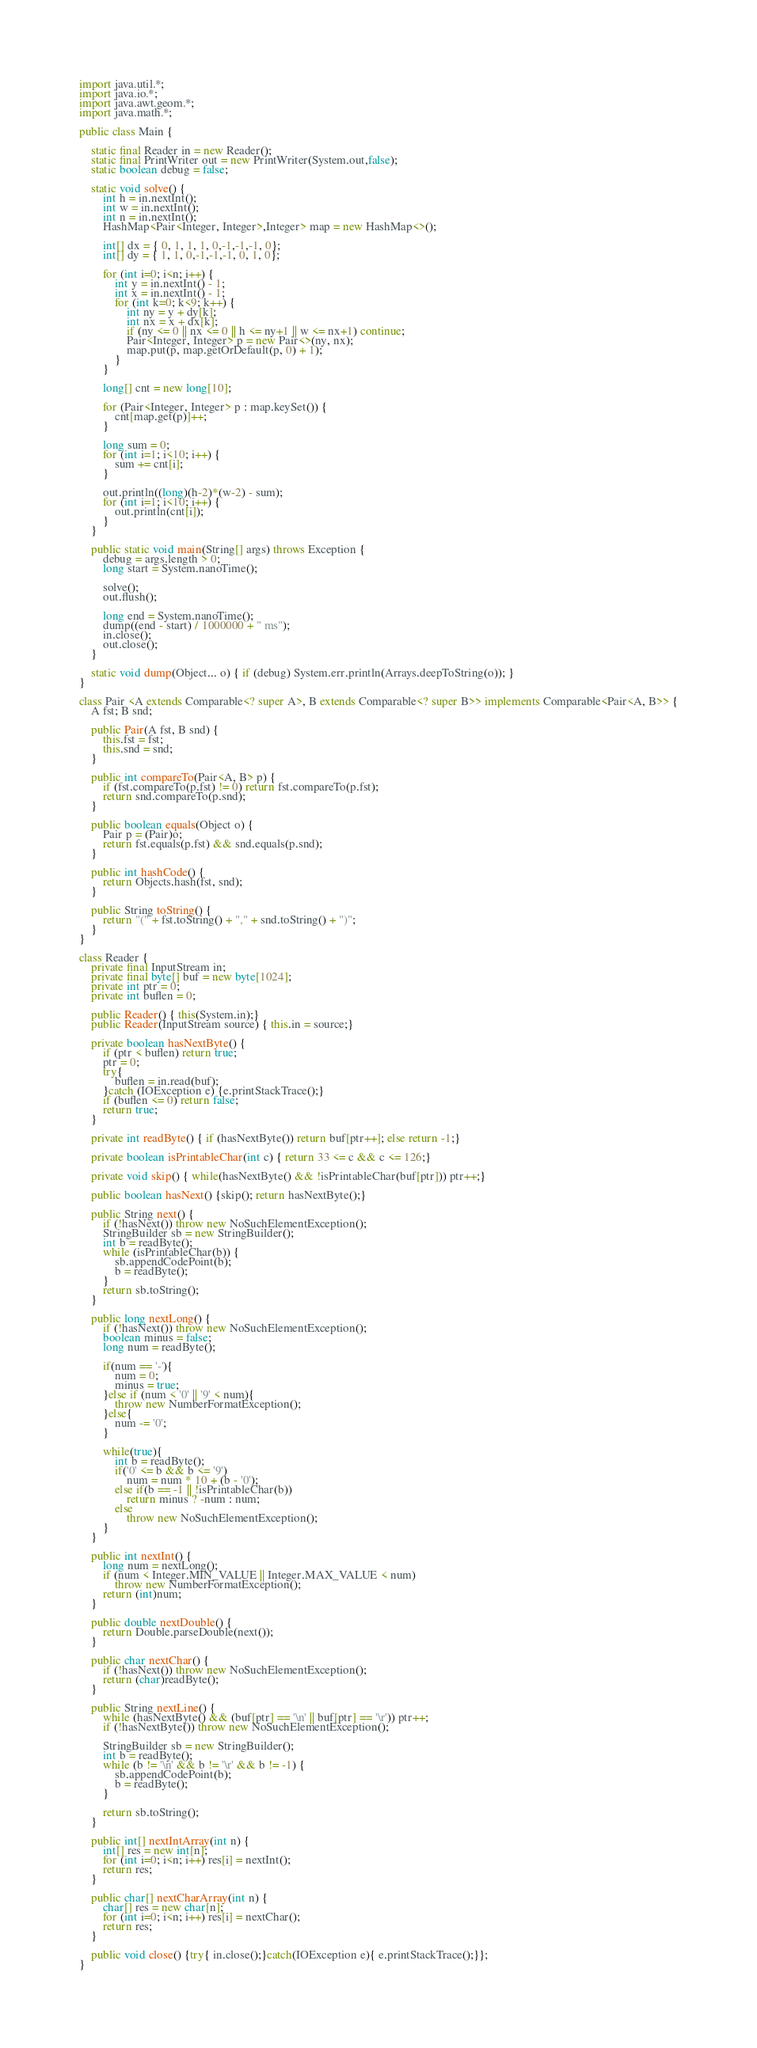<code> <loc_0><loc_0><loc_500><loc_500><_Java_>import java.util.*;
import java.io.*;
import java.awt.geom.*;
import java.math.*;

public class Main {

	static final Reader in = new Reader();
	static final PrintWriter out = new PrintWriter(System.out,false);
	static boolean debug = false;

	static void solve() {
		int h = in.nextInt();
		int w = in.nextInt();
		int n = in.nextInt();
		HashMap<Pair<Integer, Integer>,Integer> map = new HashMap<>();

		int[] dx = { 0, 1, 1, 1, 0,-1,-1,-1, 0};
		int[] dy = { 1, 1, 0,-1,-1,-1, 0, 1, 0};

		for (int i=0; i<n; i++) {
			int y = in.nextInt() - 1;
			int x = in.nextInt() - 1;
			for (int k=0; k<9; k++) {
				int ny = y + dy[k];
				int nx = x + dx[k];
				if (ny <= 0 || nx <= 0 || h <= ny+1 || w <= nx+1) continue;
				Pair<Integer, Integer> p = new Pair<>(ny, nx);
				map.put(p, map.getOrDefault(p, 0) + 1);
			}
		}

		long[] cnt = new long[10];

		for (Pair<Integer, Integer> p : map.keySet()) {
			cnt[map.get(p)]++;
		}

		long sum = 0;
		for (int i=1; i<10; i++) {
			sum += cnt[i];
		}

		out.println((long)(h-2)*(w-2) - sum);
		for (int i=1; i<10; i++) {
			out.println(cnt[i]);
		}
	}

	public static void main(String[] args) throws Exception {
		debug = args.length > 0;
		long start = System.nanoTime();

		solve();
		out.flush();

		long end = System.nanoTime();
		dump((end - start) / 1000000 + " ms");
		in.close();
		out.close();
	}

	static void dump(Object... o) { if (debug) System.err.println(Arrays.deepToString(o)); }
}

class Pair <A extends Comparable<? super A>, B extends Comparable<? super B>> implements Comparable<Pair<A, B>> {
	A fst; B snd;

	public Pair(A fst, B snd) {
		this.fst = fst;
		this.snd = snd;
	}

	public int compareTo(Pair<A, B> p) {
		if (fst.compareTo(p.fst) != 0) return fst.compareTo(p.fst);
		return snd.compareTo(p.snd);
	}

	public boolean equals(Object o) {
		Pair p = (Pair)o;
		return fst.equals(p.fst) && snd.equals(p.snd);
	}

	public int hashCode() {
		return Objects.hash(fst, snd);
	}

	public String toString() {
		return "(" + fst.toString() + "," + snd.toString() + ")";
	}
}

class Reader {
	private final InputStream in;
	private final byte[] buf = new byte[1024];
	private int ptr = 0;
	private int buflen = 0;

	public Reader() { this(System.in);}
	public Reader(InputStream source) { this.in = source;}

	private boolean hasNextByte() {
		if (ptr < buflen) return true;
		ptr = 0;
		try{
			buflen = in.read(buf);
		}catch (IOException e) {e.printStackTrace();}
		if (buflen <= 0) return false;
		return true;
	}

	private int readByte() { if (hasNextByte()) return buf[ptr++]; else return -1;}

	private boolean isPrintableChar(int c) { return 33 <= c && c <= 126;}

	private void skip() { while(hasNextByte() && !isPrintableChar(buf[ptr])) ptr++;}

	public boolean hasNext() {skip(); return hasNextByte();}

	public String next() {
		if (!hasNext()) throw new NoSuchElementException();
		StringBuilder sb = new StringBuilder();
		int b = readByte();
		while (isPrintableChar(b)) {
			sb.appendCodePoint(b);
			b = readByte();
		}
		return sb.toString();
	}

	public long nextLong() {
		if (!hasNext()) throw new NoSuchElementException();
		boolean minus = false;
		long num = readByte();

		if(num == '-'){
			num = 0;
			minus = true;
		}else if (num < '0' || '9' < num){
			throw new NumberFormatException();
		}else{
			num -= '0';
		}

		while(true){
			int b = readByte();
			if('0' <= b && b <= '9')
				num = num * 10 + (b - '0');
			else if(b == -1 || !isPrintableChar(b))
				return minus ? -num : num;
			else
				throw new NoSuchElementException();
		}
	}

	public int nextInt() {
		long num = nextLong();
		if (num < Integer.MIN_VALUE || Integer.MAX_VALUE < num)
			throw new NumberFormatException();
		return (int)num;
	}

	public double nextDouble() {
		return Double.parseDouble(next());
	}

	public char nextChar() {
		if (!hasNext()) throw new NoSuchElementException();
		return (char)readByte();
	}

	public String nextLine() {
		while (hasNextByte() && (buf[ptr] == '\n' || buf[ptr] == '\r')) ptr++;
		if (!hasNextByte()) throw new NoSuchElementException();

		StringBuilder sb = new StringBuilder();
		int b = readByte();
		while (b != '\n' && b != '\r' && b != -1) {
			sb.appendCodePoint(b);
			b = readByte();
		}

		return sb.toString();
	}

	public int[] nextIntArray(int n) {
		int[] res = new int[n];
		for (int i=0; i<n; i++) res[i] = nextInt();
		return res;
	}

	public char[] nextCharArray(int n) {
		char[] res = new char[n];
		for (int i=0; i<n; i++) res[i] = nextChar();
		return res;
	}

	public void close() {try{ in.close();}catch(IOException e){ e.printStackTrace();}};
}</code> 